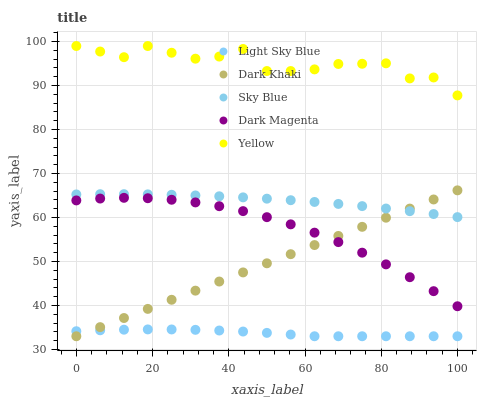Does Light Sky Blue have the minimum area under the curve?
Answer yes or no. Yes. Does Yellow have the maximum area under the curve?
Answer yes or no. Yes. Does Sky Blue have the minimum area under the curve?
Answer yes or no. No. Does Sky Blue have the maximum area under the curve?
Answer yes or no. No. Is Dark Khaki the smoothest?
Answer yes or no. Yes. Is Yellow the roughest?
Answer yes or no. Yes. Is Sky Blue the smoothest?
Answer yes or no. No. Is Sky Blue the roughest?
Answer yes or no. No. Does Dark Khaki have the lowest value?
Answer yes or no. Yes. Does Sky Blue have the lowest value?
Answer yes or no. No. Does Yellow have the highest value?
Answer yes or no. Yes. Does Sky Blue have the highest value?
Answer yes or no. No. Is Dark Magenta less than Sky Blue?
Answer yes or no. Yes. Is Yellow greater than Sky Blue?
Answer yes or no. Yes. Does Sky Blue intersect Dark Khaki?
Answer yes or no. Yes. Is Sky Blue less than Dark Khaki?
Answer yes or no. No. Is Sky Blue greater than Dark Khaki?
Answer yes or no. No. Does Dark Magenta intersect Sky Blue?
Answer yes or no. No. 